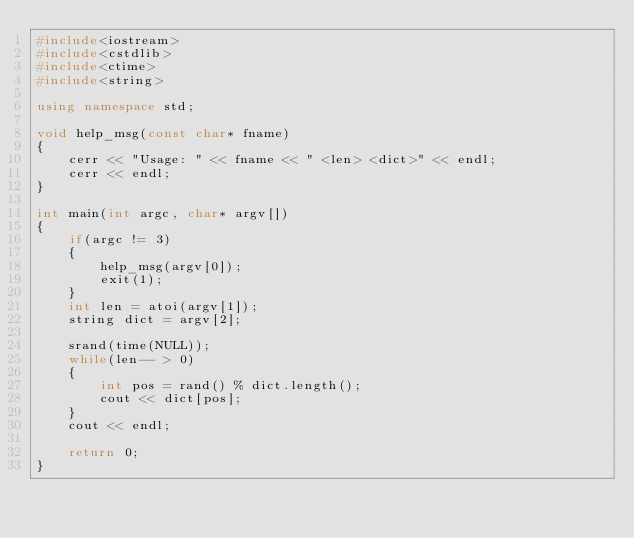<code> <loc_0><loc_0><loc_500><loc_500><_C++_>#include<iostream>
#include<cstdlib>
#include<ctime>
#include<string>

using namespace std;

void help_msg(const char* fname)
{
    cerr << "Usage: " << fname << " <len> <dict>" << endl;
    cerr << endl;
}

int main(int argc, char* argv[])
{
    if(argc != 3)
    {
        help_msg(argv[0]);
        exit(1);
    }
    int len = atoi(argv[1]);
    string dict = argv[2];

    srand(time(NULL));
    while(len-- > 0)
    {
        int pos = rand() % dict.length();
        cout << dict[pos];
    }
    cout << endl;
    
    return 0;
}
</code> 